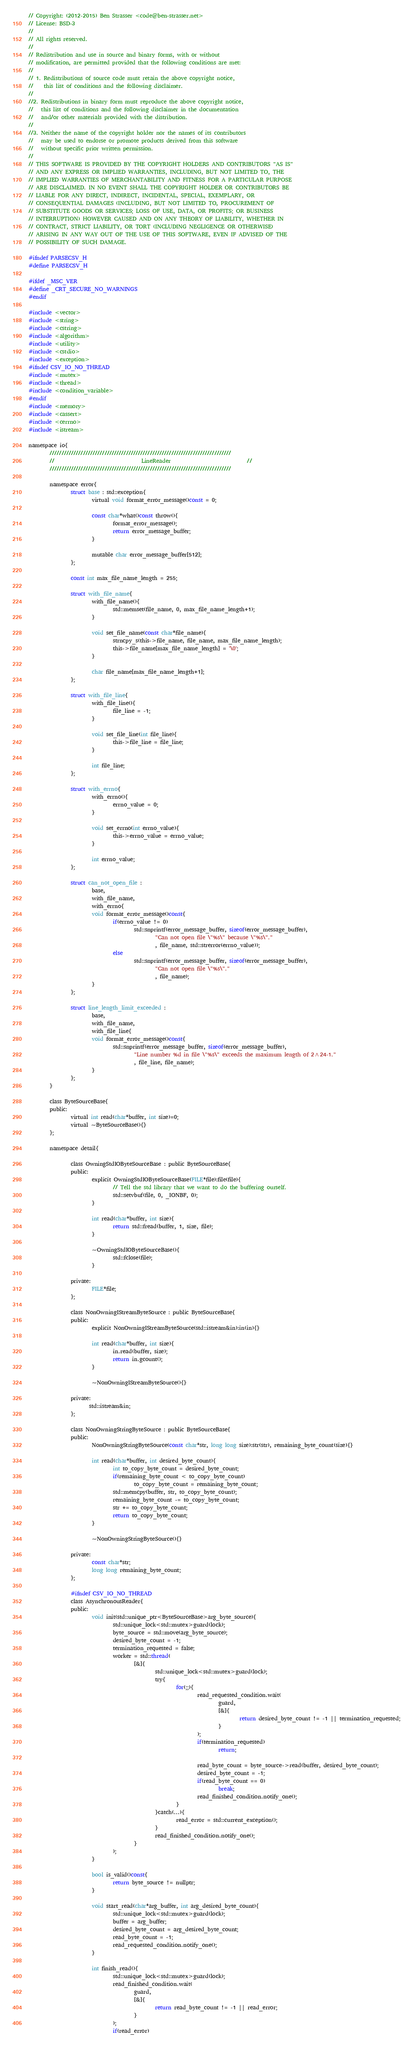<code> <loc_0><loc_0><loc_500><loc_500><_C_>// Copyright: (2012-2015) Ben Strasser <code@ben-strasser.net>
// License: BSD-3
//
// All rights reserved.
//
// Redistribution and use in source and binary forms, with or without
// modification, are permitted provided that the following conditions are met:
//
// 1. Redistributions of source code must retain the above copyright notice,
//    this list of conditions and the following disclaimer.
//
//2. Redistributions in binary form must reproduce the above copyright notice,
//   this list of conditions and the following disclaimer in the documentation
//   and/or other materials provided with the distribution.
//
//3. Neither the name of the copyright holder nor the names of its contributors
//   may be used to endorse or promote products derived from this software
//   without specific prior written permission.
//
// THIS SOFTWARE IS PROVIDED BY THE COPYRIGHT HOLDERS AND CONTRIBUTORS "AS IS"
// AND ANY EXPRESS OR IMPLIED WARRANTIES, INCLUDING, BUT NOT LIMITED TO, THE
// IMPLIED WARRANTIES OF MERCHANTABILITY AND FITNESS FOR A PARTICULAR PURPOSE
// ARE DISCLAIMED. IN NO EVENT SHALL THE COPYRIGHT HOLDER OR CONTRIBUTORS BE
// LIABLE FOR ANY DIRECT, INDIRECT, INCIDENTAL, SPECIAL, EXEMPLARY, OR
// CONSEQUENTIAL DAMAGES (INCLUDING, BUT NOT LIMITED TO, PROCUREMENT OF
// SUBSTITUTE GOODS OR SERVICES; LOSS OF USE, DATA, OR PROFITS; OR BUSINESS
// INTERRUPTION) HOWEVER CAUSED AND ON ANY THEORY OF LIABILITY, WHETHER IN
// CONTRACT, STRICT LIABILITY, OR TORT (INCLUDING NEGLIGENCE OR OTHERWISE)
// ARISING IN ANY WAY OUT OF THE USE OF THIS SOFTWARE, EVEN IF ADVISED OF THE
// POSSIBILITY OF SUCH DAMAGE.

#ifndef PARSECSV_H
#define PARSECSV_H

#ifdef _MSC_VER
#define _CRT_SECURE_NO_WARNINGS
#endif

#include <vector>
#include <string>
#include <cstring>
#include <algorithm>
#include <utility>
#include <cstdio>
#include <exception>
#ifndef CSV_IO_NO_THREAD
#include <mutex>
#include <thread>
#include <condition_variable>
#endif
#include <memory>
#include <cassert>
#include <cerrno>
#include <istream>

namespace io{
        ////////////////////////////////////////////////////////////////////////////
        //                                 LineReader                             //
        ////////////////////////////////////////////////////////////////////////////

        namespace error{
                struct base : std::exception{
                        virtual void format_error_message()const = 0;                          
                       
                        const char*what()const throw(){
                                format_error_message();
                                return error_message_buffer;
                        }

                        mutable char error_message_buffer[512];
                };

                const int max_file_name_length = 255;

                struct with_file_name{
                        with_file_name(){
                                std::memset(file_name, 0, max_file_name_length+1);
                        }
                       
                        void set_file_name(const char*file_name){
                                strncpy_s(this->file_name, file_name, max_file_name_length);
                                this->file_name[max_file_name_length] = '\0';
                        }

                        char file_name[max_file_name_length+1];
                };

                struct with_file_line{
                        with_file_line(){
                                file_line = -1;
                        }
                       
                        void set_file_line(int file_line){
                                this->file_line = file_line;
                        }

                        int file_line;
                };

                struct with_errno{
                        with_errno(){
                                errno_value = 0;
                        }
                       
                        void set_errno(int errno_value){
                                this->errno_value = errno_value;
                        }

                        int errno_value;
                };

                struct can_not_open_file :
                        base,
                        with_file_name,
                        with_errno{
                        void format_error_message()const{
                                if(errno_value != 0)
                                        std::snprintf(error_message_buffer, sizeof(error_message_buffer),
                                                "Can not open file \"%s\" because \"%s\"."
                                                , file_name, std::strerror(errno_value));
                                else
                                        std::snprintf(error_message_buffer, sizeof(error_message_buffer),
                                                "Can not open file \"%s\"."
                                                , file_name);
                        }
                };

                struct line_length_limit_exceeded :
                        base,
                        with_file_name,
                        with_file_line{
                        void format_error_message()const{
                                std::snprintf(error_message_buffer, sizeof(error_message_buffer),
                                        "Line number %d in file \"%s\" exceeds the maximum length of 2^24-1."
                                        , file_line, file_name);
                        }
                };
        }

        class ByteSourceBase{
        public:
                virtual int read(char*buffer, int size)=0;
                virtual ~ByteSourceBase(){}
        };

        namespace detail{

                class OwningStdIOByteSourceBase : public ByteSourceBase{
                public:
                        explicit OwningStdIOByteSourceBase(FILE*file):file(file){
                                // Tell the std library that we want to do the buffering ourself.
                                std::setvbuf(file, 0, _IONBF, 0);
                        }

                        int read(char*buffer, int size){
                                return std::fread(buffer, 1, size, file);
                        }

                        ~OwningStdIOByteSourceBase(){
                                std::fclose(file);
                        }

                private:
                        FILE*file;
                };

                class NonOwningIStreamByteSource : public ByteSourceBase{
                public:
                        explicit NonOwningIStreamByteSource(std::istream&in):in(in){}

                        int read(char*buffer, int size){
                                in.read(buffer, size);
                                return in.gcount();
                        }

                        ~NonOwningIStreamByteSource(){}

                private:
                       std::istream&in;
                };

                class NonOwningStringByteSource : public ByteSourceBase{
                public:
                        NonOwningStringByteSource(const char*str, long long size):str(str), remaining_byte_count(size){}

                        int read(char*buffer, int desired_byte_count){
                                int to_copy_byte_count = desired_byte_count;
                                if(remaining_byte_count < to_copy_byte_count)
                                        to_copy_byte_count = remaining_byte_count;
                                std::memcpy(buffer, str, to_copy_byte_count);
                                remaining_byte_count -= to_copy_byte_count;
                                str += to_copy_byte_count;
                                return to_copy_byte_count;
                        }

                        ~NonOwningStringByteSource(){}

                private:
                        const char*str;
                        long long remaining_byte_count;
                };

                #ifndef CSV_IO_NO_THREAD
                class AsynchronousReader{
                public:
                        void init(std::unique_ptr<ByteSourceBase>arg_byte_source){
                                std::unique_lock<std::mutex>guard(lock);
                                byte_source = std::move(arg_byte_source);
                                desired_byte_count = -1;
                                termination_requested = false;
                                worker = std::thread(
                                        [&]{
                                                std::unique_lock<std::mutex>guard(lock);
                                                try{
                                                        for(;;){
                                                                read_requested_condition.wait(
                                                                        guard, 
                                                                        [&]{
                                                                                return desired_byte_count != -1 || termination_requested;
                                                                        }
                                                                );
                                                                if(termination_requested)
                                                                        return;

                                                                read_byte_count = byte_source->read(buffer, desired_byte_count);
                                                                desired_byte_count = -1;
                                                                if(read_byte_count == 0)
                                                                        break;
                                                                read_finished_condition.notify_one();
                                                        }
                                                }catch(...){
                                                        read_error = std::current_exception();
                                                }
                                                read_finished_condition.notify_one();
                                        }
                                );
                        }

                        bool is_valid()const{
                                return byte_source != nullptr;
                        }

                        void start_read(char*arg_buffer, int arg_desired_byte_count){
                                std::unique_lock<std::mutex>guard(lock);
                                buffer = arg_buffer;
                                desired_byte_count = arg_desired_byte_count;
                                read_byte_count = -1;
                                read_requested_condition.notify_one();
                        }

                        int finish_read(){
                                std::unique_lock<std::mutex>guard(lock);
                                read_finished_condition.wait(
                                        guard, 
                                        [&]{
                                                return read_byte_count != -1 || read_error;
                                        }
                                );
                                if(read_error)</code> 